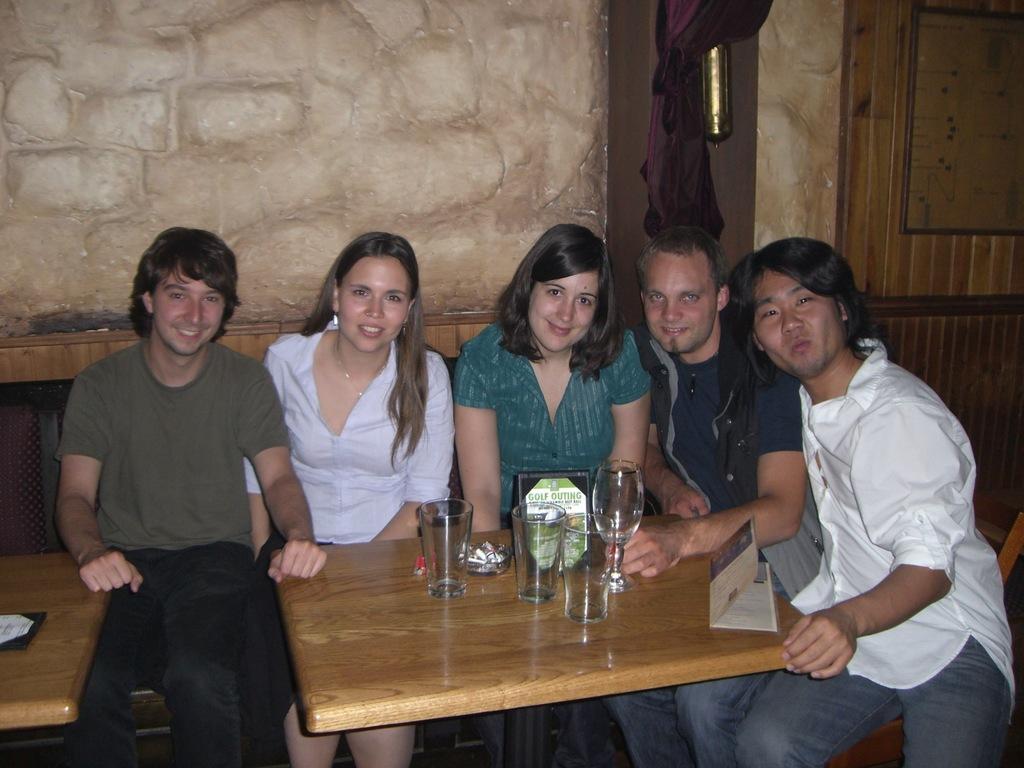In one or two sentences, can you explain what this image depicts? In this image we have a group of people who are sitting on the chair and bench in front of the wooden table. On the table we have couple of glasses and the other objects. The person are smiling, behind this person we have a wall and a curtain. 